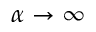Convert formula to latex. <formula><loc_0><loc_0><loc_500><loc_500>\alpha \to \infty</formula> 